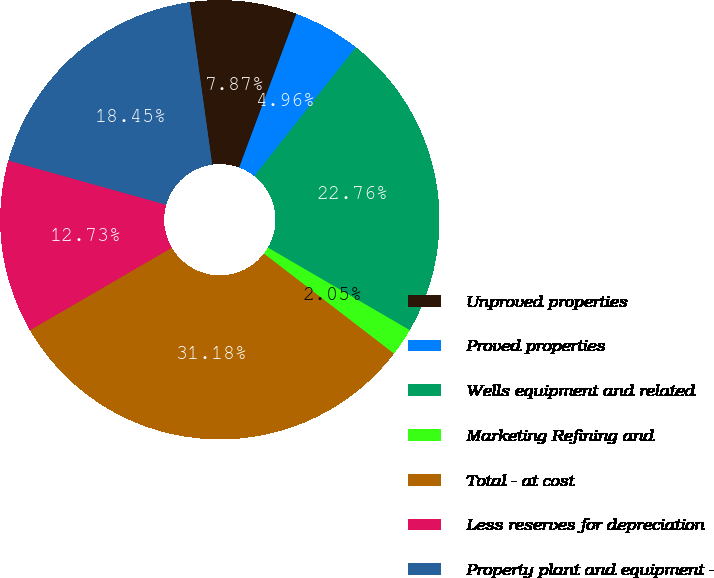Convert chart. <chart><loc_0><loc_0><loc_500><loc_500><pie_chart><fcel>Unproved properties<fcel>Proved properties<fcel>Wells equipment and related<fcel>Marketing Refining and<fcel>Total - at cost<fcel>Less reserves for depreciation<fcel>Property plant and equipment -<nl><fcel>7.87%<fcel>4.96%<fcel>22.76%<fcel>2.05%<fcel>31.18%<fcel>12.73%<fcel>18.45%<nl></chart> 